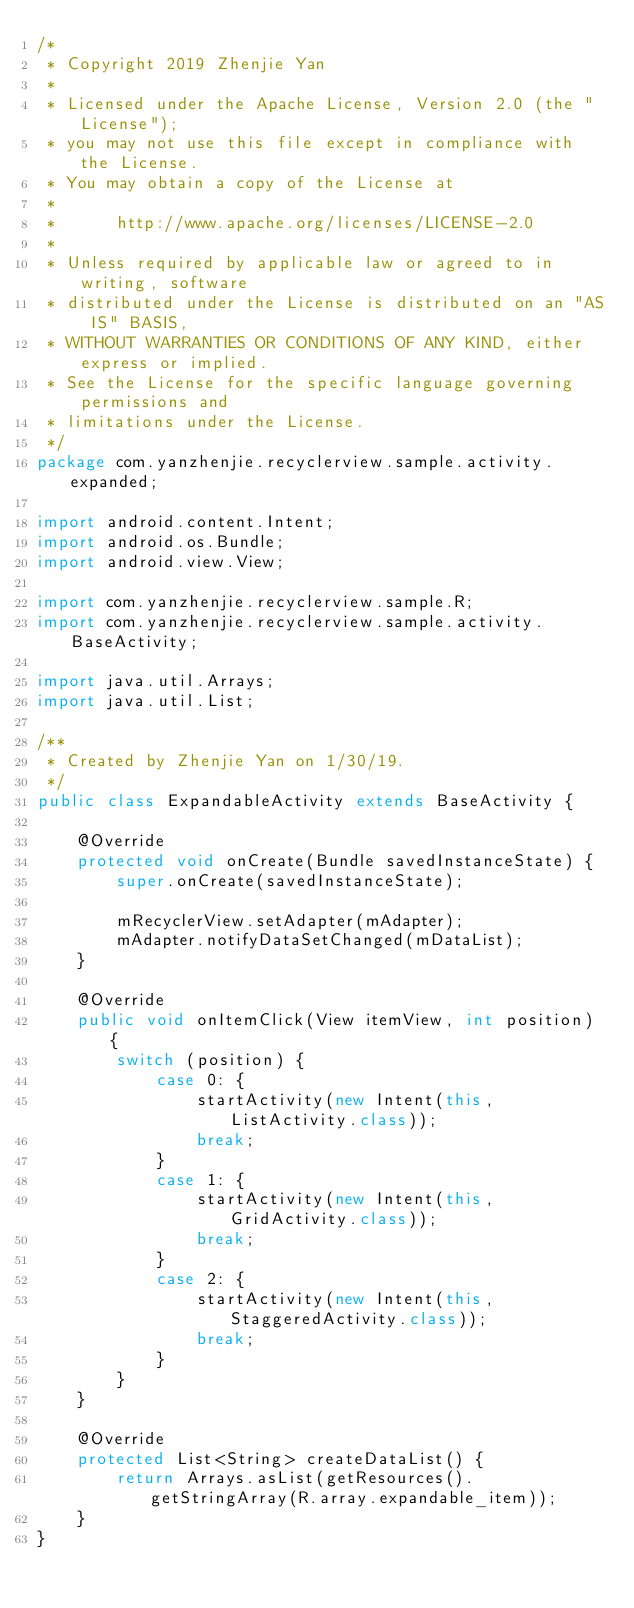<code> <loc_0><loc_0><loc_500><loc_500><_Java_>/*
 * Copyright 2019 Zhenjie Yan
 *
 * Licensed under the Apache License, Version 2.0 (the "License");
 * you may not use this file except in compliance with the License.
 * You may obtain a copy of the License at
 *
 *      http://www.apache.org/licenses/LICENSE-2.0
 *
 * Unless required by applicable law or agreed to in writing, software
 * distributed under the License is distributed on an "AS IS" BASIS,
 * WITHOUT WARRANTIES OR CONDITIONS OF ANY KIND, either express or implied.
 * See the License for the specific language governing permissions and
 * limitations under the License.
 */
package com.yanzhenjie.recyclerview.sample.activity.expanded;

import android.content.Intent;
import android.os.Bundle;
import android.view.View;

import com.yanzhenjie.recyclerview.sample.R;
import com.yanzhenjie.recyclerview.sample.activity.BaseActivity;

import java.util.Arrays;
import java.util.List;

/**
 * Created by Zhenjie Yan on 1/30/19.
 */
public class ExpandableActivity extends BaseActivity {

    @Override
    protected void onCreate(Bundle savedInstanceState) {
        super.onCreate(savedInstanceState);

        mRecyclerView.setAdapter(mAdapter);
        mAdapter.notifyDataSetChanged(mDataList);
    }

    @Override
    public void onItemClick(View itemView, int position) {
        switch (position) {
            case 0: {
                startActivity(new Intent(this, ListActivity.class));
                break;
            }
            case 1: {
                startActivity(new Intent(this, GridActivity.class));
                break;
            }
            case 2: {
                startActivity(new Intent(this, StaggeredActivity.class));
                break;
            }
        }
    }

    @Override
    protected List<String> createDataList() {
        return Arrays.asList(getResources().getStringArray(R.array.expandable_item));
    }
}</code> 